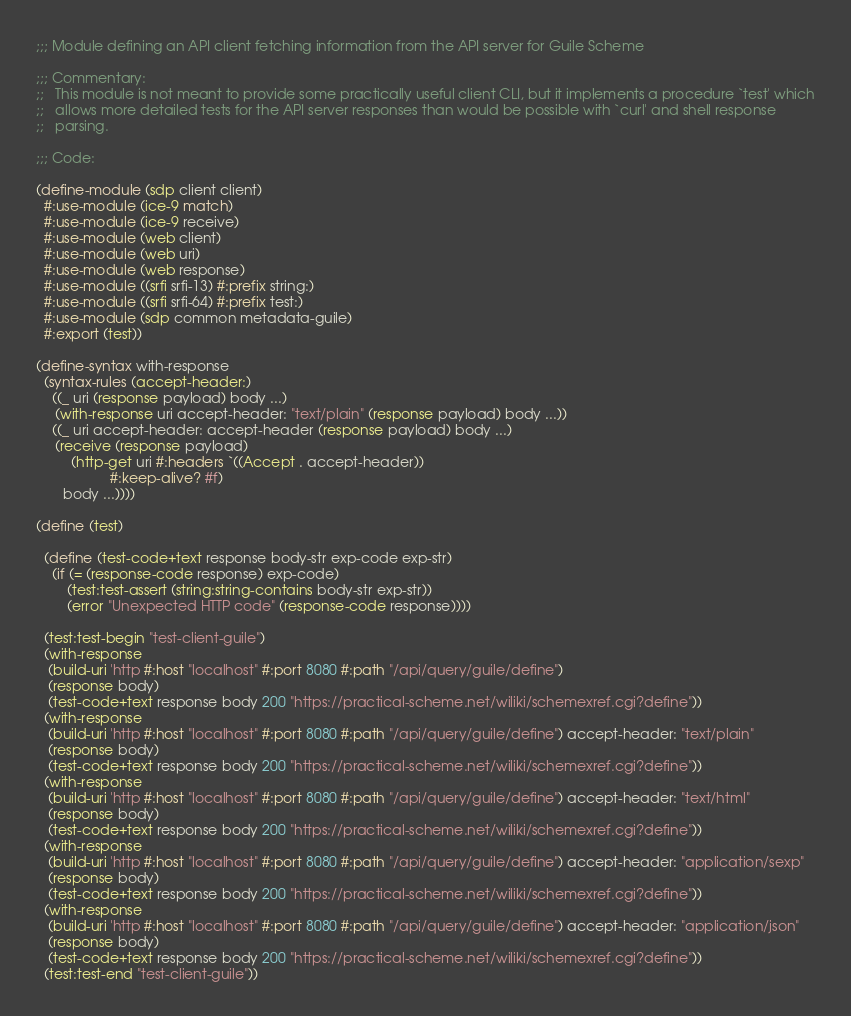Convert code to text. <code><loc_0><loc_0><loc_500><loc_500><_Scheme_>;;; Module defining an API client fetching information from the API server for Guile Scheme

;;; Commentary:
;;   This module is not meant to provide some practically useful client CLI, but it implements a procedure `test' which
;;   allows more detailed tests for the API server responses than would be possible with `curl' and shell response
;;   parsing.

;;; Code:

(define-module (sdp client client)
  #:use-module (ice-9 match)
  #:use-module (ice-9 receive)
  #:use-module (web client)
  #:use-module (web uri)
  #:use-module (web response)
  #:use-module ((srfi srfi-13) #:prefix string:)
  #:use-module ((srfi srfi-64) #:prefix test:)
  #:use-module (sdp common metadata-guile)
  #:export (test))

(define-syntax with-response
  (syntax-rules (accept-header:)
    ((_ uri (response payload) body ...)
     (with-response uri accept-header: "text/plain" (response payload) body ...))
    ((_ uri accept-header: accept-header (response payload) body ...)
     (receive (response payload)
         (http-get uri #:headers `((Accept . accept-header))
                   #:keep-alive? #f)
       body ...))))

(define (test)

  (define (test-code+text response body-str exp-code exp-str)
    (if (= (response-code response) exp-code)
        (test:test-assert (string:string-contains body-str exp-str))
        (error "Unexpected HTTP code" (response-code response))))

  (test:test-begin "test-client-guile")
  (with-response
   (build-uri 'http #:host "localhost" #:port 8080 #:path "/api/query/guile/define")
   (response body)
   (test-code+text response body 200 "https://practical-scheme.net/wiliki/schemexref.cgi?define"))
  (with-response
   (build-uri 'http #:host "localhost" #:port 8080 #:path "/api/query/guile/define") accept-header: "text/plain"
   (response body)
   (test-code+text response body 200 "https://practical-scheme.net/wiliki/schemexref.cgi?define"))
  (with-response
   (build-uri 'http #:host "localhost" #:port 8080 #:path "/api/query/guile/define") accept-header: "text/html"
   (response body)
   (test-code+text response body 200 "https://practical-scheme.net/wiliki/schemexref.cgi?define"))
  (with-response
   (build-uri 'http #:host "localhost" #:port 8080 #:path "/api/query/guile/define") accept-header: "application/sexp"
   (response body)
   (test-code+text response body 200 "https://practical-scheme.net/wiliki/schemexref.cgi?define"))
  (with-response
   (build-uri 'http #:host "localhost" #:port 8080 #:path "/api/query/guile/define") accept-header: "application/json"
   (response body)
   (test-code+text response body 200 "https://practical-scheme.net/wiliki/schemexref.cgi?define"))
  (test:test-end "test-client-guile"))
</code> 